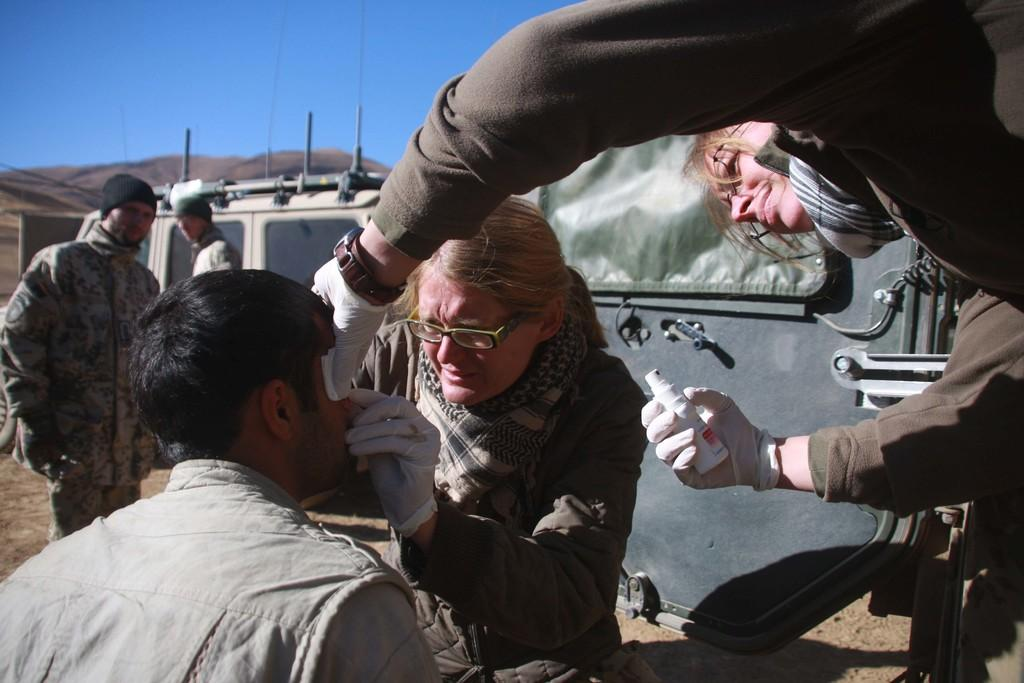How many people are in the image? There are people in the image, but the exact number is not specified. What is the person on the right holding? The person on the right is holding a spray. What can be seen in the background of the image? There are vehicles and hills visible in the background of the image. What is visible at the top of the image? The sky is visible at the top of the image. How many beetles can be seen crawling on the lake in the image? There is no lake or beetles present in the image. What number is written on the side of the vehicles in the background? The facts provided do not mention any numbers on the vehicles, so we cannot determine that information. 